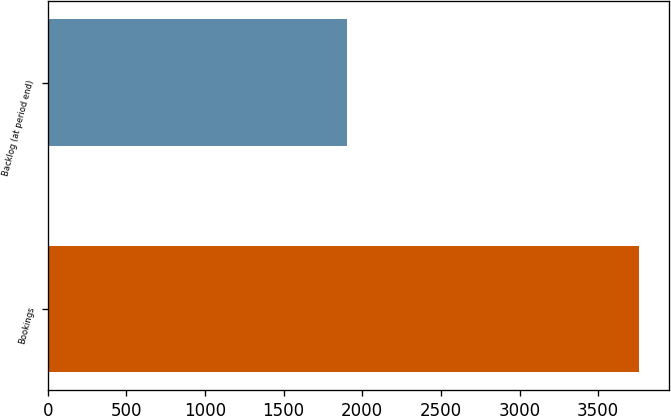<chart> <loc_0><loc_0><loc_500><loc_500><bar_chart><fcel>Bookings<fcel>Backlog (at period end)<nl><fcel>3760.4<fcel>1901.8<nl></chart> 